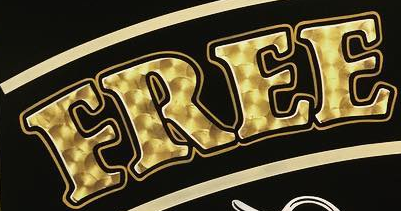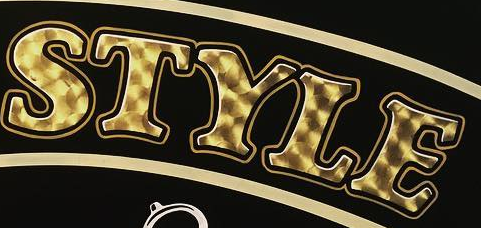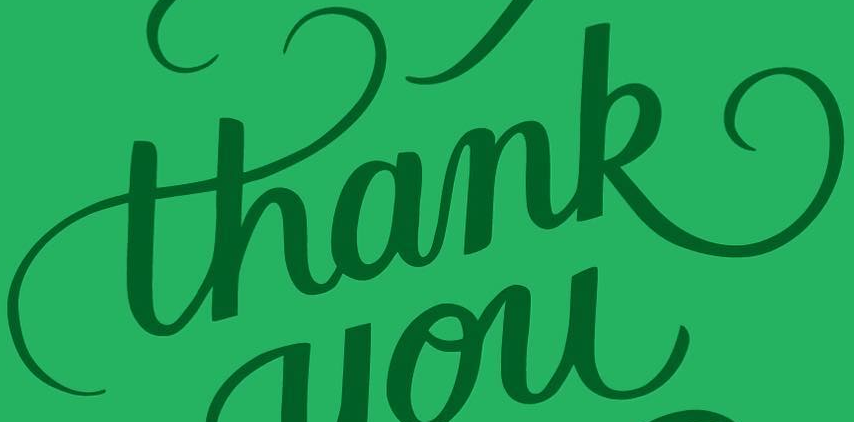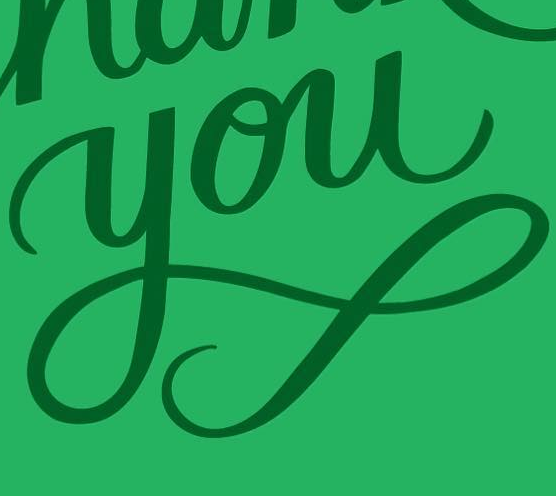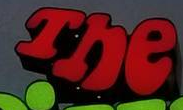Read the text content from these images in order, separated by a semicolon. FREE; STYLE; thank; you; The 